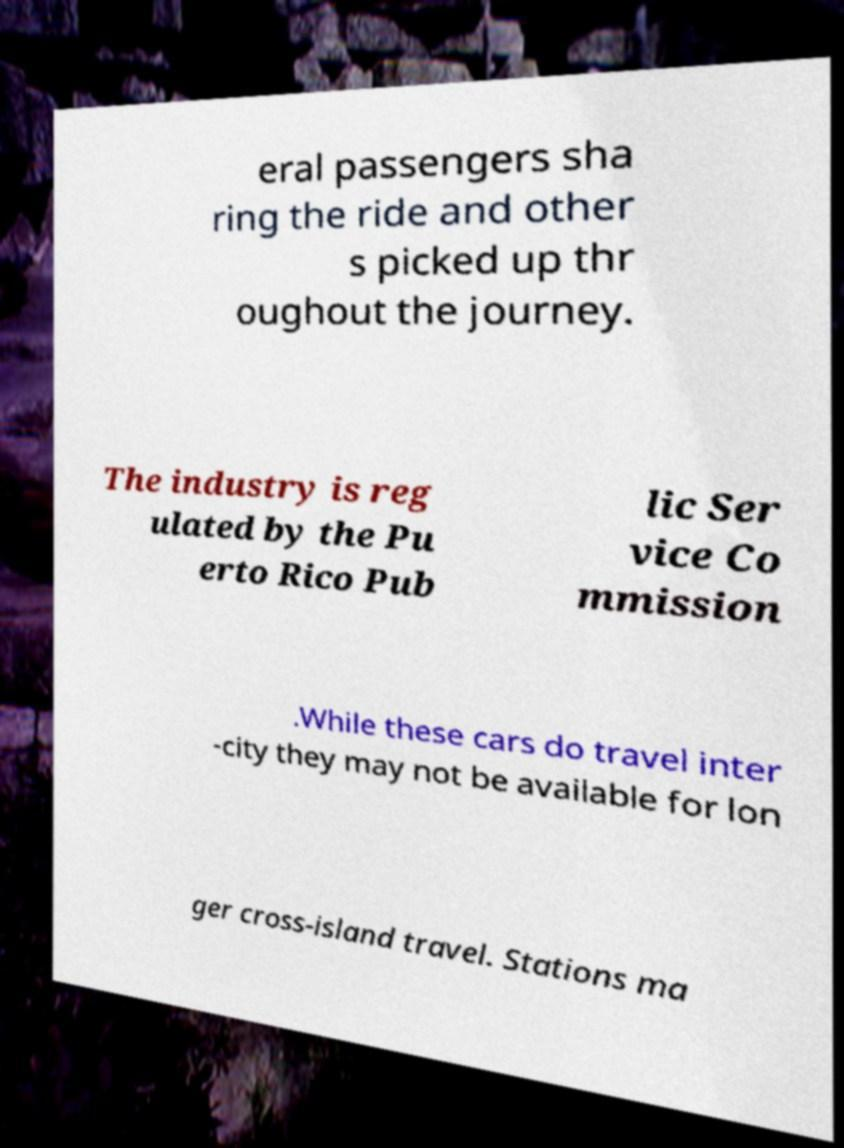What messages or text are displayed in this image? I need them in a readable, typed format. eral passengers sha ring the ride and other s picked up thr oughout the journey. The industry is reg ulated by the Pu erto Rico Pub lic Ser vice Co mmission .While these cars do travel inter -city they may not be available for lon ger cross-island travel. Stations ma 